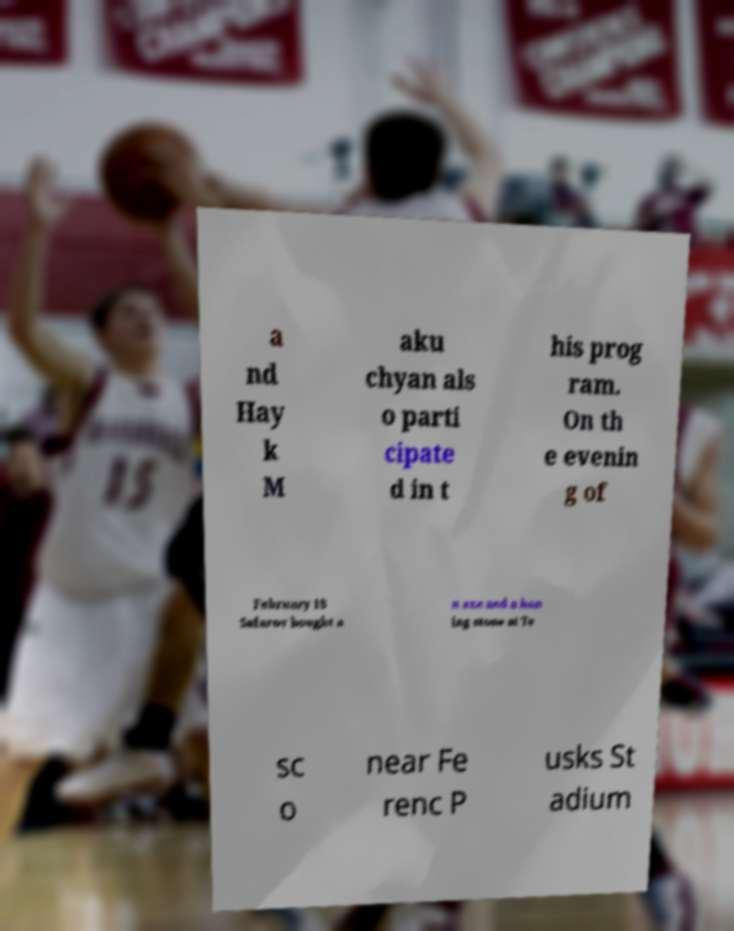Please identify and transcribe the text found in this image. a nd Hay k M aku chyan als o parti cipate d in t his prog ram. On th e evenin g of February 18 Safarov bought a n axe and a hon ing stone at Te sc o near Fe renc P usks St adium 